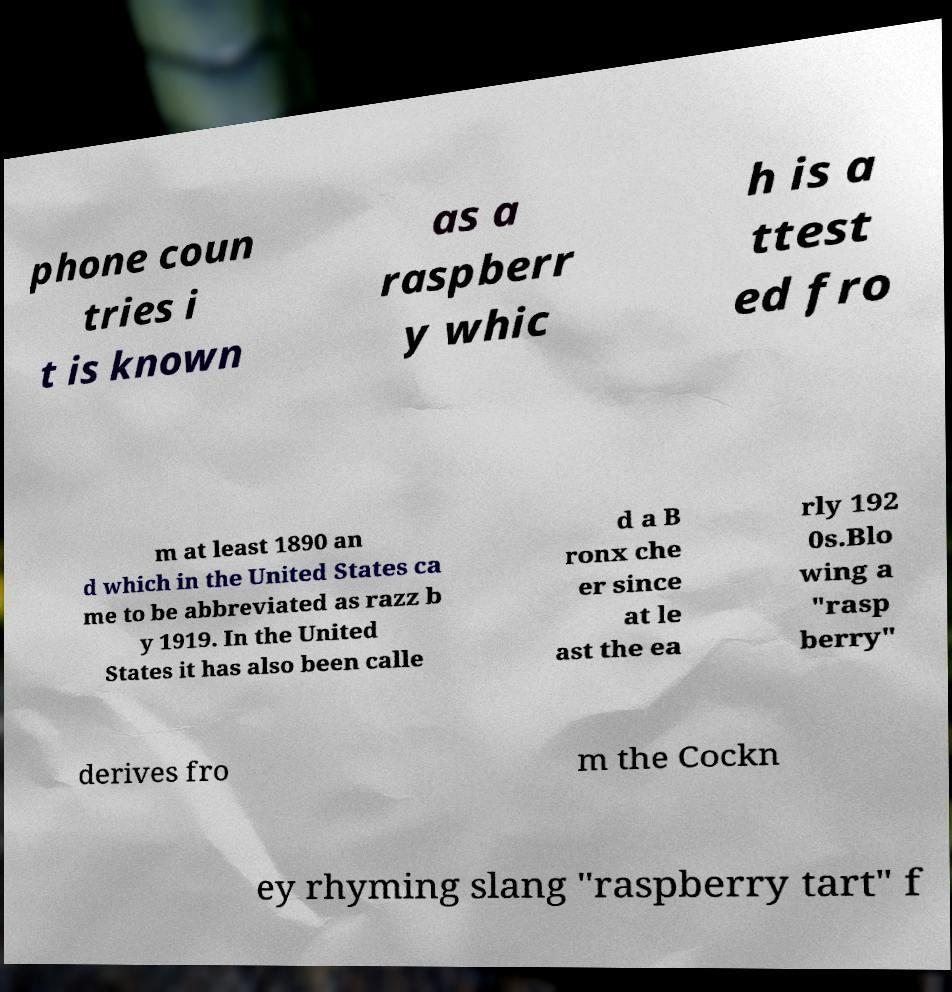Can you accurately transcribe the text from the provided image for me? phone coun tries i t is known as a raspberr y whic h is a ttest ed fro m at least 1890 an d which in the United States ca me to be abbreviated as razz b y 1919. In the United States it has also been calle d a B ronx che er since at le ast the ea rly 192 0s.Blo wing a "rasp berry" derives fro m the Cockn ey rhyming slang "raspberry tart" f 